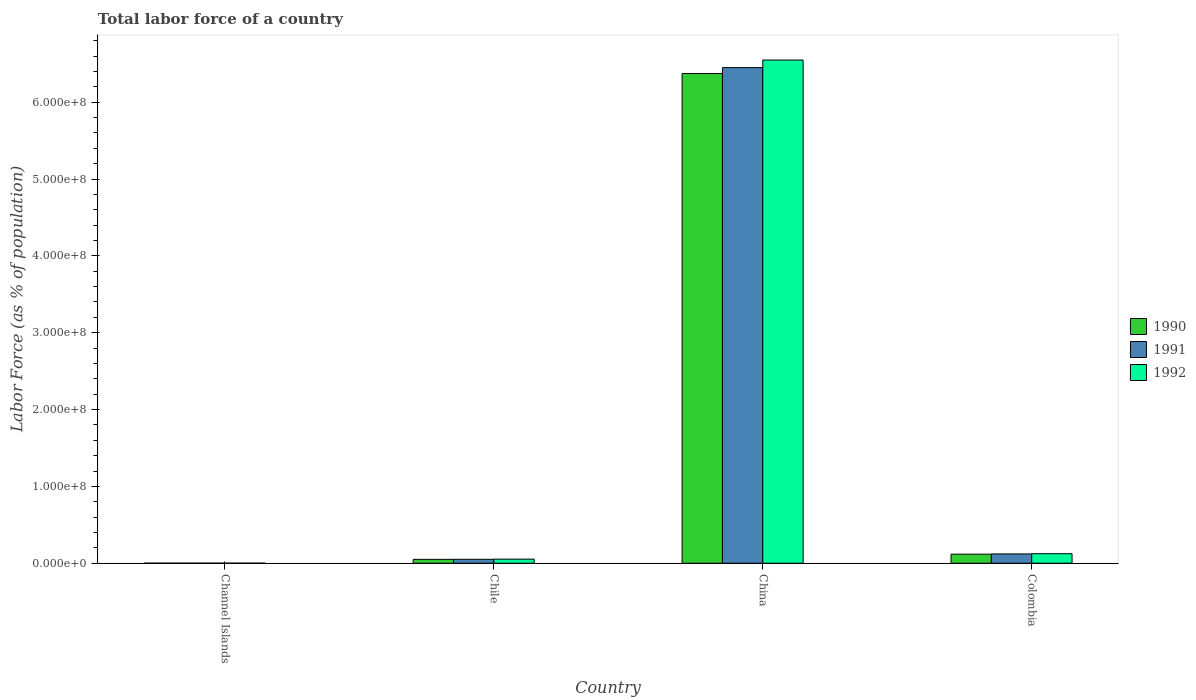Are the number of bars on each tick of the X-axis equal?
Offer a terse response. Yes. In how many cases, is the number of bars for a given country not equal to the number of legend labels?
Keep it short and to the point. 0. What is the percentage of labor force in 1990 in Channel Islands?
Offer a very short reply. 6.71e+04. Across all countries, what is the maximum percentage of labor force in 1990?
Your response must be concise. 6.37e+08. Across all countries, what is the minimum percentage of labor force in 1990?
Keep it short and to the point. 6.71e+04. In which country was the percentage of labor force in 1992 maximum?
Give a very brief answer. China. In which country was the percentage of labor force in 1990 minimum?
Your answer should be compact. Channel Islands. What is the total percentage of labor force in 1991 in the graph?
Your answer should be very brief. 6.62e+08. What is the difference between the percentage of labor force in 1990 in Chile and that in China?
Your response must be concise. -6.32e+08. What is the difference between the percentage of labor force in 1992 in China and the percentage of labor force in 1990 in Chile?
Provide a succinct answer. 6.50e+08. What is the average percentage of labor force in 1992 per country?
Offer a terse response. 1.68e+08. What is the difference between the percentage of labor force of/in 1992 and percentage of labor force of/in 1990 in China?
Your answer should be very brief. 1.76e+07. What is the ratio of the percentage of labor force in 1990 in Chile to that in China?
Give a very brief answer. 0.01. Is the percentage of labor force in 1992 in China less than that in Colombia?
Your answer should be very brief. No. What is the difference between the highest and the second highest percentage of labor force in 1992?
Offer a very short reply. -7.06e+06. What is the difference between the highest and the lowest percentage of labor force in 1991?
Your answer should be very brief. 6.45e+08. What does the 2nd bar from the left in China represents?
Your response must be concise. 1991. What does the 3rd bar from the right in Colombia represents?
Ensure brevity in your answer.  1990. Are all the bars in the graph horizontal?
Keep it short and to the point. No. How many countries are there in the graph?
Provide a succinct answer. 4. Does the graph contain any zero values?
Offer a terse response. No. How many legend labels are there?
Ensure brevity in your answer.  3. What is the title of the graph?
Provide a succinct answer. Total labor force of a country. Does "1987" appear as one of the legend labels in the graph?
Make the answer very short. No. What is the label or title of the X-axis?
Make the answer very short. Country. What is the label or title of the Y-axis?
Give a very brief answer. Labor Force (as % of population). What is the Labor Force (as % of population) of 1990 in Channel Islands?
Keep it short and to the point. 6.71e+04. What is the Labor Force (as % of population) in 1991 in Channel Islands?
Offer a terse response. 6.79e+04. What is the Labor Force (as % of population) in 1992 in Channel Islands?
Provide a succinct answer. 6.87e+04. What is the Labor Force (as % of population) in 1990 in Chile?
Provide a succinct answer. 5.03e+06. What is the Labor Force (as % of population) of 1991 in Chile?
Your response must be concise. 5.11e+06. What is the Labor Force (as % of population) of 1992 in Chile?
Make the answer very short. 5.32e+06. What is the Labor Force (as % of population) of 1990 in China?
Offer a very short reply. 6.37e+08. What is the Labor Force (as % of population) of 1991 in China?
Give a very brief answer. 6.45e+08. What is the Labor Force (as % of population) of 1992 in China?
Your response must be concise. 6.55e+08. What is the Labor Force (as % of population) in 1990 in Colombia?
Your answer should be very brief. 1.18e+07. What is the Labor Force (as % of population) of 1991 in Colombia?
Your response must be concise. 1.21e+07. What is the Labor Force (as % of population) of 1992 in Colombia?
Offer a terse response. 1.24e+07. Across all countries, what is the maximum Labor Force (as % of population) in 1990?
Provide a short and direct response. 6.37e+08. Across all countries, what is the maximum Labor Force (as % of population) in 1991?
Your answer should be compact. 6.45e+08. Across all countries, what is the maximum Labor Force (as % of population) in 1992?
Provide a succinct answer. 6.55e+08. Across all countries, what is the minimum Labor Force (as % of population) in 1990?
Provide a short and direct response. 6.71e+04. Across all countries, what is the minimum Labor Force (as % of population) in 1991?
Ensure brevity in your answer.  6.79e+04. Across all countries, what is the minimum Labor Force (as % of population) in 1992?
Give a very brief answer. 6.87e+04. What is the total Labor Force (as % of population) of 1990 in the graph?
Your response must be concise. 6.54e+08. What is the total Labor Force (as % of population) of 1991 in the graph?
Ensure brevity in your answer.  6.62e+08. What is the total Labor Force (as % of population) of 1992 in the graph?
Make the answer very short. 6.73e+08. What is the difference between the Labor Force (as % of population) of 1990 in Channel Islands and that in Chile?
Offer a very short reply. -4.96e+06. What is the difference between the Labor Force (as % of population) of 1991 in Channel Islands and that in Chile?
Offer a very short reply. -5.04e+06. What is the difference between the Labor Force (as % of population) in 1992 in Channel Islands and that in Chile?
Provide a short and direct response. -5.25e+06. What is the difference between the Labor Force (as % of population) of 1990 in Channel Islands and that in China?
Offer a terse response. -6.37e+08. What is the difference between the Labor Force (as % of population) in 1991 in Channel Islands and that in China?
Make the answer very short. -6.45e+08. What is the difference between the Labor Force (as % of population) in 1992 in Channel Islands and that in China?
Offer a very short reply. -6.55e+08. What is the difference between the Labor Force (as % of population) in 1990 in Channel Islands and that in Colombia?
Your answer should be compact. -1.17e+07. What is the difference between the Labor Force (as % of population) of 1991 in Channel Islands and that in Colombia?
Your response must be concise. -1.20e+07. What is the difference between the Labor Force (as % of population) in 1992 in Channel Islands and that in Colombia?
Make the answer very short. -1.23e+07. What is the difference between the Labor Force (as % of population) of 1990 in Chile and that in China?
Your answer should be very brief. -6.32e+08. What is the difference between the Labor Force (as % of population) in 1991 in Chile and that in China?
Your answer should be compact. -6.40e+08. What is the difference between the Labor Force (as % of population) in 1992 in Chile and that in China?
Offer a terse response. -6.50e+08. What is the difference between the Labor Force (as % of population) in 1990 in Chile and that in Colombia?
Your response must be concise. -6.75e+06. What is the difference between the Labor Force (as % of population) of 1991 in Chile and that in Colombia?
Ensure brevity in your answer.  -6.98e+06. What is the difference between the Labor Force (as % of population) of 1992 in Chile and that in Colombia?
Offer a very short reply. -7.06e+06. What is the difference between the Labor Force (as % of population) of 1990 in China and that in Colombia?
Provide a succinct answer. 6.26e+08. What is the difference between the Labor Force (as % of population) of 1991 in China and that in Colombia?
Ensure brevity in your answer.  6.33e+08. What is the difference between the Labor Force (as % of population) in 1992 in China and that in Colombia?
Offer a very short reply. 6.43e+08. What is the difference between the Labor Force (as % of population) of 1990 in Channel Islands and the Labor Force (as % of population) of 1991 in Chile?
Your answer should be compact. -5.04e+06. What is the difference between the Labor Force (as % of population) in 1990 in Channel Islands and the Labor Force (as % of population) in 1992 in Chile?
Provide a short and direct response. -5.25e+06. What is the difference between the Labor Force (as % of population) in 1991 in Channel Islands and the Labor Force (as % of population) in 1992 in Chile?
Offer a very short reply. -5.25e+06. What is the difference between the Labor Force (as % of population) of 1990 in Channel Islands and the Labor Force (as % of population) of 1991 in China?
Provide a short and direct response. -6.45e+08. What is the difference between the Labor Force (as % of population) of 1990 in Channel Islands and the Labor Force (as % of population) of 1992 in China?
Your answer should be very brief. -6.55e+08. What is the difference between the Labor Force (as % of population) of 1991 in Channel Islands and the Labor Force (as % of population) of 1992 in China?
Keep it short and to the point. -6.55e+08. What is the difference between the Labor Force (as % of population) of 1990 in Channel Islands and the Labor Force (as % of population) of 1991 in Colombia?
Offer a very short reply. -1.20e+07. What is the difference between the Labor Force (as % of population) in 1990 in Channel Islands and the Labor Force (as % of population) in 1992 in Colombia?
Offer a very short reply. -1.23e+07. What is the difference between the Labor Force (as % of population) of 1991 in Channel Islands and the Labor Force (as % of population) of 1992 in Colombia?
Make the answer very short. -1.23e+07. What is the difference between the Labor Force (as % of population) of 1990 in Chile and the Labor Force (as % of population) of 1991 in China?
Make the answer very short. -6.40e+08. What is the difference between the Labor Force (as % of population) in 1990 in Chile and the Labor Force (as % of population) in 1992 in China?
Your answer should be compact. -6.50e+08. What is the difference between the Labor Force (as % of population) of 1991 in Chile and the Labor Force (as % of population) of 1992 in China?
Offer a terse response. -6.50e+08. What is the difference between the Labor Force (as % of population) in 1990 in Chile and the Labor Force (as % of population) in 1991 in Colombia?
Provide a succinct answer. -7.06e+06. What is the difference between the Labor Force (as % of population) of 1990 in Chile and the Labor Force (as % of population) of 1992 in Colombia?
Provide a short and direct response. -7.36e+06. What is the difference between the Labor Force (as % of population) of 1991 in Chile and the Labor Force (as % of population) of 1992 in Colombia?
Your answer should be very brief. -7.27e+06. What is the difference between the Labor Force (as % of population) in 1990 in China and the Labor Force (as % of population) in 1991 in Colombia?
Offer a terse response. 6.25e+08. What is the difference between the Labor Force (as % of population) of 1990 in China and the Labor Force (as % of population) of 1992 in Colombia?
Make the answer very short. 6.25e+08. What is the difference between the Labor Force (as % of population) of 1991 in China and the Labor Force (as % of population) of 1992 in Colombia?
Your answer should be very brief. 6.33e+08. What is the average Labor Force (as % of population) in 1990 per country?
Your answer should be compact. 1.64e+08. What is the average Labor Force (as % of population) in 1991 per country?
Your answer should be compact. 1.66e+08. What is the average Labor Force (as % of population) of 1992 per country?
Ensure brevity in your answer.  1.68e+08. What is the difference between the Labor Force (as % of population) in 1990 and Labor Force (as % of population) in 1991 in Channel Islands?
Keep it short and to the point. -765. What is the difference between the Labor Force (as % of population) in 1990 and Labor Force (as % of population) in 1992 in Channel Islands?
Offer a very short reply. -1587. What is the difference between the Labor Force (as % of population) in 1991 and Labor Force (as % of population) in 1992 in Channel Islands?
Make the answer very short. -822. What is the difference between the Labor Force (as % of population) in 1990 and Labor Force (as % of population) in 1991 in Chile?
Offer a very short reply. -8.28e+04. What is the difference between the Labor Force (as % of population) of 1990 and Labor Force (as % of population) of 1992 in Chile?
Ensure brevity in your answer.  -2.95e+05. What is the difference between the Labor Force (as % of population) in 1991 and Labor Force (as % of population) in 1992 in Chile?
Your answer should be very brief. -2.12e+05. What is the difference between the Labor Force (as % of population) of 1990 and Labor Force (as % of population) of 1991 in China?
Your answer should be compact. -7.70e+06. What is the difference between the Labor Force (as % of population) in 1990 and Labor Force (as % of population) in 1992 in China?
Provide a succinct answer. -1.76e+07. What is the difference between the Labor Force (as % of population) in 1991 and Labor Force (as % of population) in 1992 in China?
Your answer should be compact. -9.86e+06. What is the difference between the Labor Force (as % of population) in 1990 and Labor Force (as % of population) in 1991 in Colombia?
Your response must be concise. -3.13e+05. What is the difference between the Labor Force (as % of population) in 1990 and Labor Force (as % of population) in 1992 in Colombia?
Your answer should be very brief. -6.06e+05. What is the difference between the Labor Force (as % of population) of 1991 and Labor Force (as % of population) of 1992 in Colombia?
Offer a terse response. -2.93e+05. What is the ratio of the Labor Force (as % of population) in 1990 in Channel Islands to that in Chile?
Keep it short and to the point. 0.01. What is the ratio of the Labor Force (as % of population) in 1991 in Channel Islands to that in Chile?
Your response must be concise. 0.01. What is the ratio of the Labor Force (as % of population) of 1992 in Channel Islands to that in Chile?
Keep it short and to the point. 0.01. What is the ratio of the Labor Force (as % of population) in 1990 in Channel Islands to that in China?
Give a very brief answer. 0. What is the ratio of the Labor Force (as % of population) of 1991 in Channel Islands to that in China?
Keep it short and to the point. 0. What is the ratio of the Labor Force (as % of population) in 1992 in Channel Islands to that in China?
Keep it short and to the point. 0. What is the ratio of the Labor Force (as % of population) of 1990 in Channel Islands to that in Colombia?
Your response must be concise. 0.01. What is the ratio of the Labor Force (as % of population) in 1991 in Channel Islands to that in Colombia?
Give a very brief answer. 0.01. What is the ratio of the Labor Force (as % of population) of 1992 in Channel Islands to that in Colombia?
Your answer should be very brief. 0.01. What is the ratio of the Labor Force (as % of population) in 1990 in Chile to that in China?
Provide a short and direct response. 0.01. What is the ratio of the Labor Force (as % of population) of 1991 in Chile to that in China?
Your response must be concise. 0.01. What is the ratio of the Labor Force (as % of population) in 1992 in Chile to that in China?
Give a very brief answer. 0.01. What is the ratio of the Labor Force (as % of population) in 1990 in Chile to that in Colombia?
Keep it short and to the point. 0.43. What is the ratio of the Labor Force (as % of population) of 1991 in Chile to that in Colombia?
Provide a succinct answer. 0.42. What is the ratio of the Labor Force (as % of population) of 1992 in Chile to that in Colombia?
Offer a terse response. 0.43. What is the ratio of the Labor Force (as % of population) in 1990 in China to that in Colombia?
Offer a terse response. 54.12. What is the ratio of the Labor Force (as % of population) of 1991 in China to that in Colombia?
Make the answer very short. 53.36. What is the ratio of the Labor Force (as % of population) in 1992 in China to that in Colombia?
Provide a short and direct response. 52.89. What is the difference between the highest and the second highest Labor Force (as % of population) in 1990?
Provide a short and direct response. 6.26e+08. What is the difference between the highest and the second highest Labor Force (as % of population) in 1991?
Your answer should be very brief. 6.33e+08. What is the difference between the highest and the second highest Labor Force (as % of population) of 1992?
Your answer should be very brief. 6.43e+08. What is the difference between the highest and the lowest Labor Force (as % of population) of 1990?
Provide a short and direct response. 6.37e+08. What is the difference between the highest and the lowest Labor Force (as % of population) in 1991?
Keep it short and to the point. 6.45e+08. What is the difference between the highest and the lowest Labor Force (as % of population) of 1992?
Make the answer very short. 6.55e+08. 